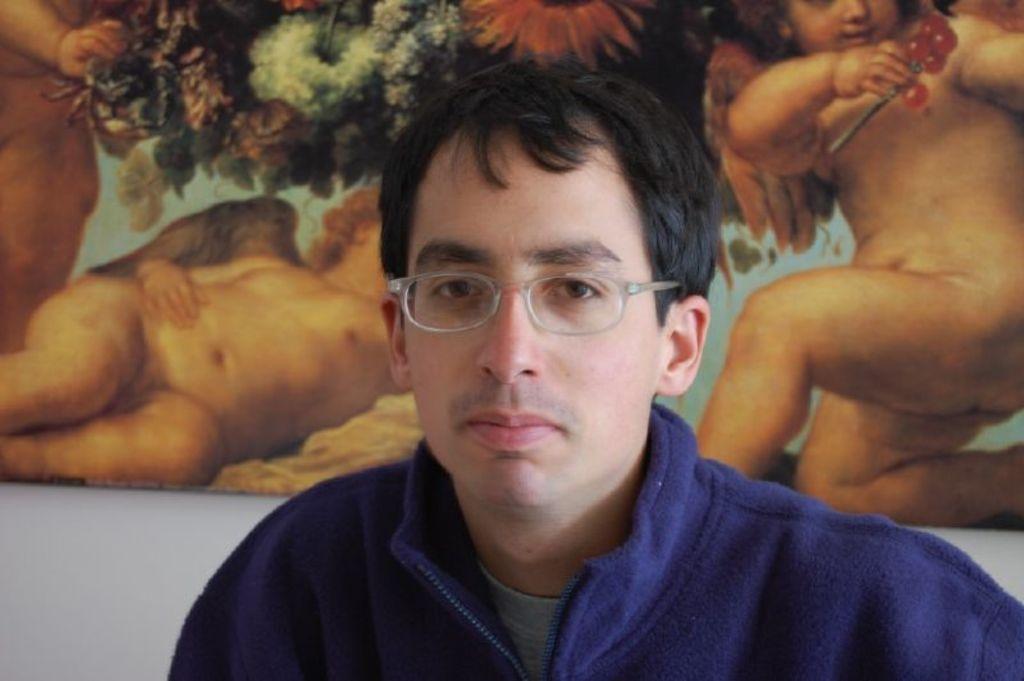Could you give a brief overview of what you see in this image? In this image there is a person standing, behind him there is a wall with poster on it, where we can see there are some kids holding fruits and also there are flowers at the middle. 